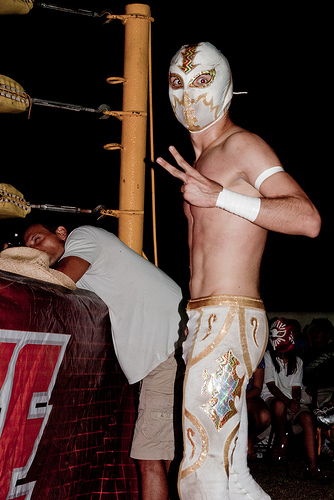<image>
Is the wrestler on the victim? Yes. Looking at the image, I can see the wrestler is positioned on top of the victim, with the victim providing support. Is the man to the left of the man? Yes. From this viewpoint, the man is positioned to the left side relative to the man. 